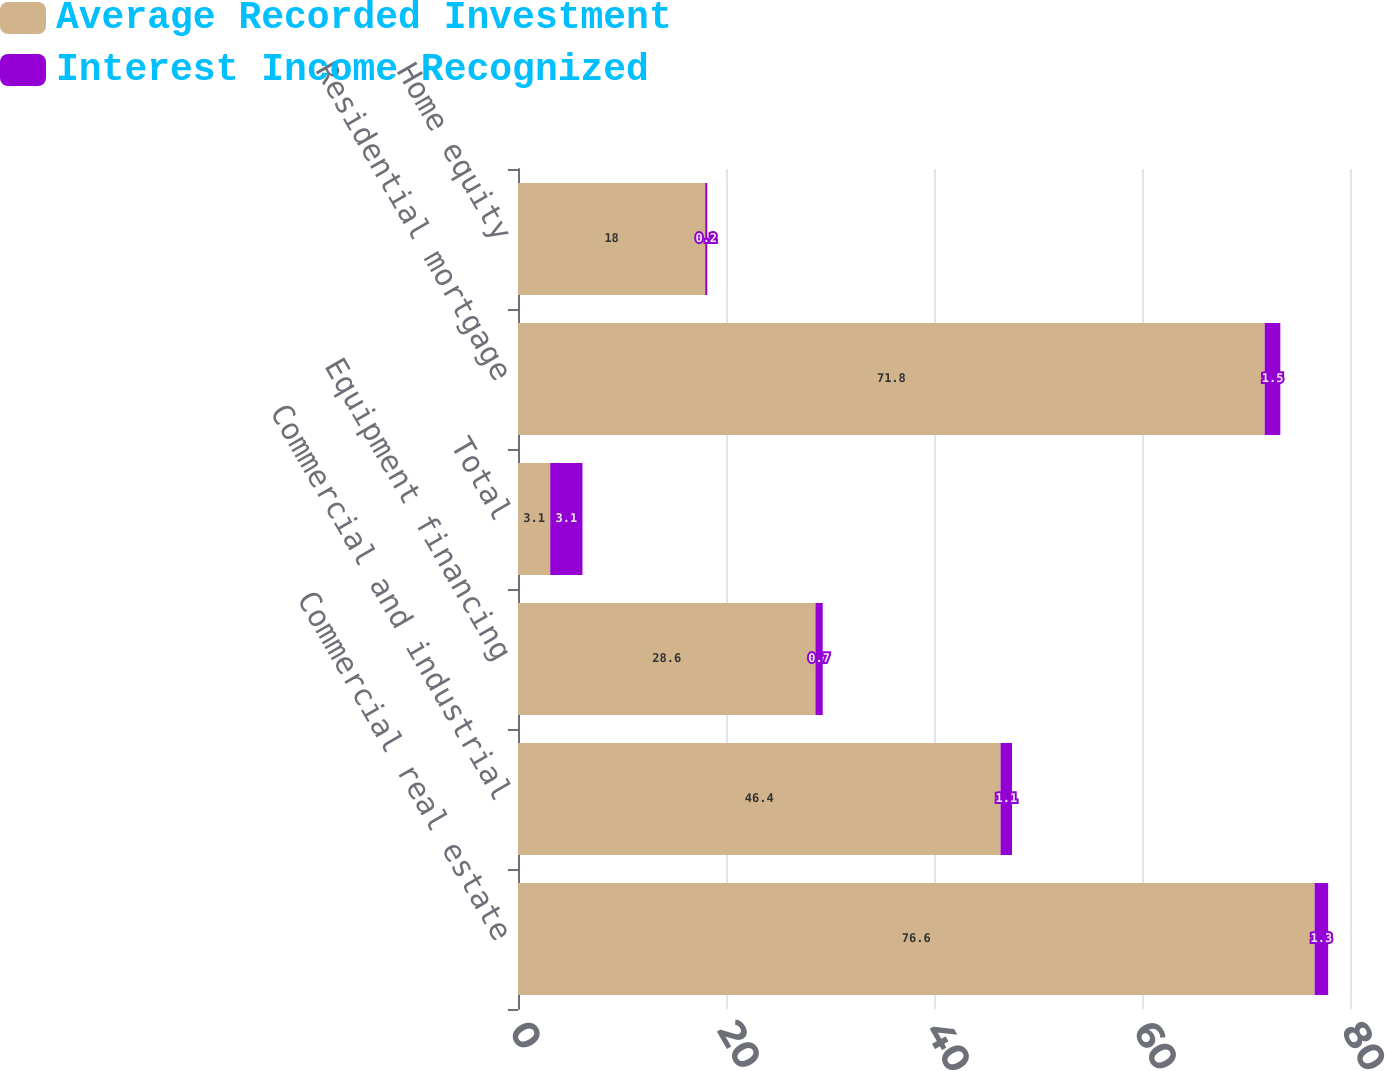<chart> <loc_0><loc_0><loc_500><loc_500><stacked_bar_chart><ecel><fcel>Commercial real estate<fcel>Commercial and industrial<fcel>Equipment financing<fcel>Total<fcel>Residential mortgage<fcel>Home equity<nl><fcel>Average Recorded Investment<fcel>76.6<fcel>46.4<fcel>28.6<fcel>3.1<fcel>71.8<fcel>18<nl><fcel>Interest Income Recognized<fcel>1.3<fcel>1.1<fcel>0.7<fcel>3.1<fcel>1.5<fcel>0.2<nl></chart> 